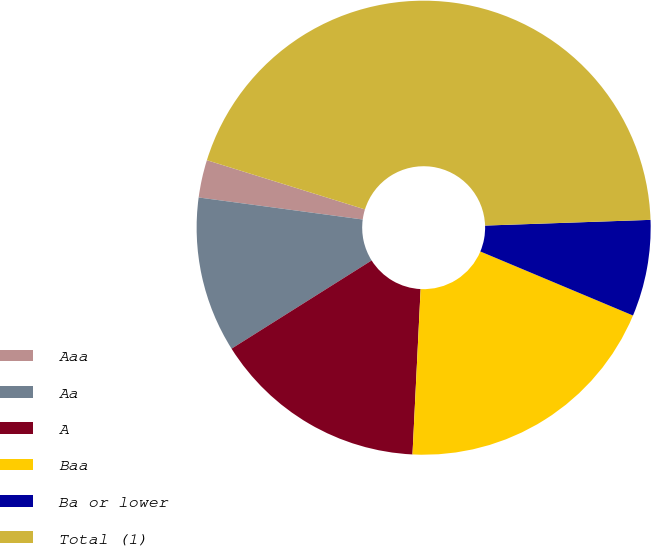Convert chart to OTSL. <chart><loc_0><loc_0><loc_500><loc_500><pie_chart><fcel>Aaa<fcel>Aa<fcel>A<fcel>Baa<fcel>Ba or lower<fcel>Total (1)<nl><fcel>2.68%<fcel>11.07%<fcel>15.27%<fcel>19.46%<fcel>6.87%<fcel>44.64%<nl></chart> 